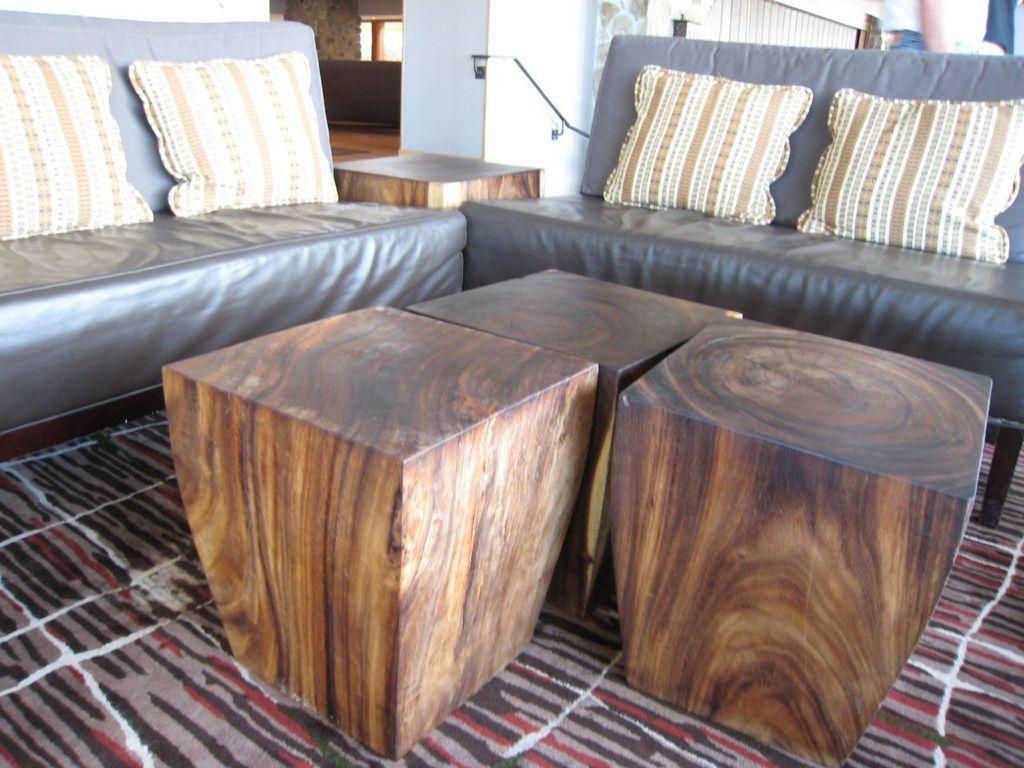How would you summarize this image in a sentence or two? In this picture there is a sofa, pillow , wooden tables. There is a carpet. 